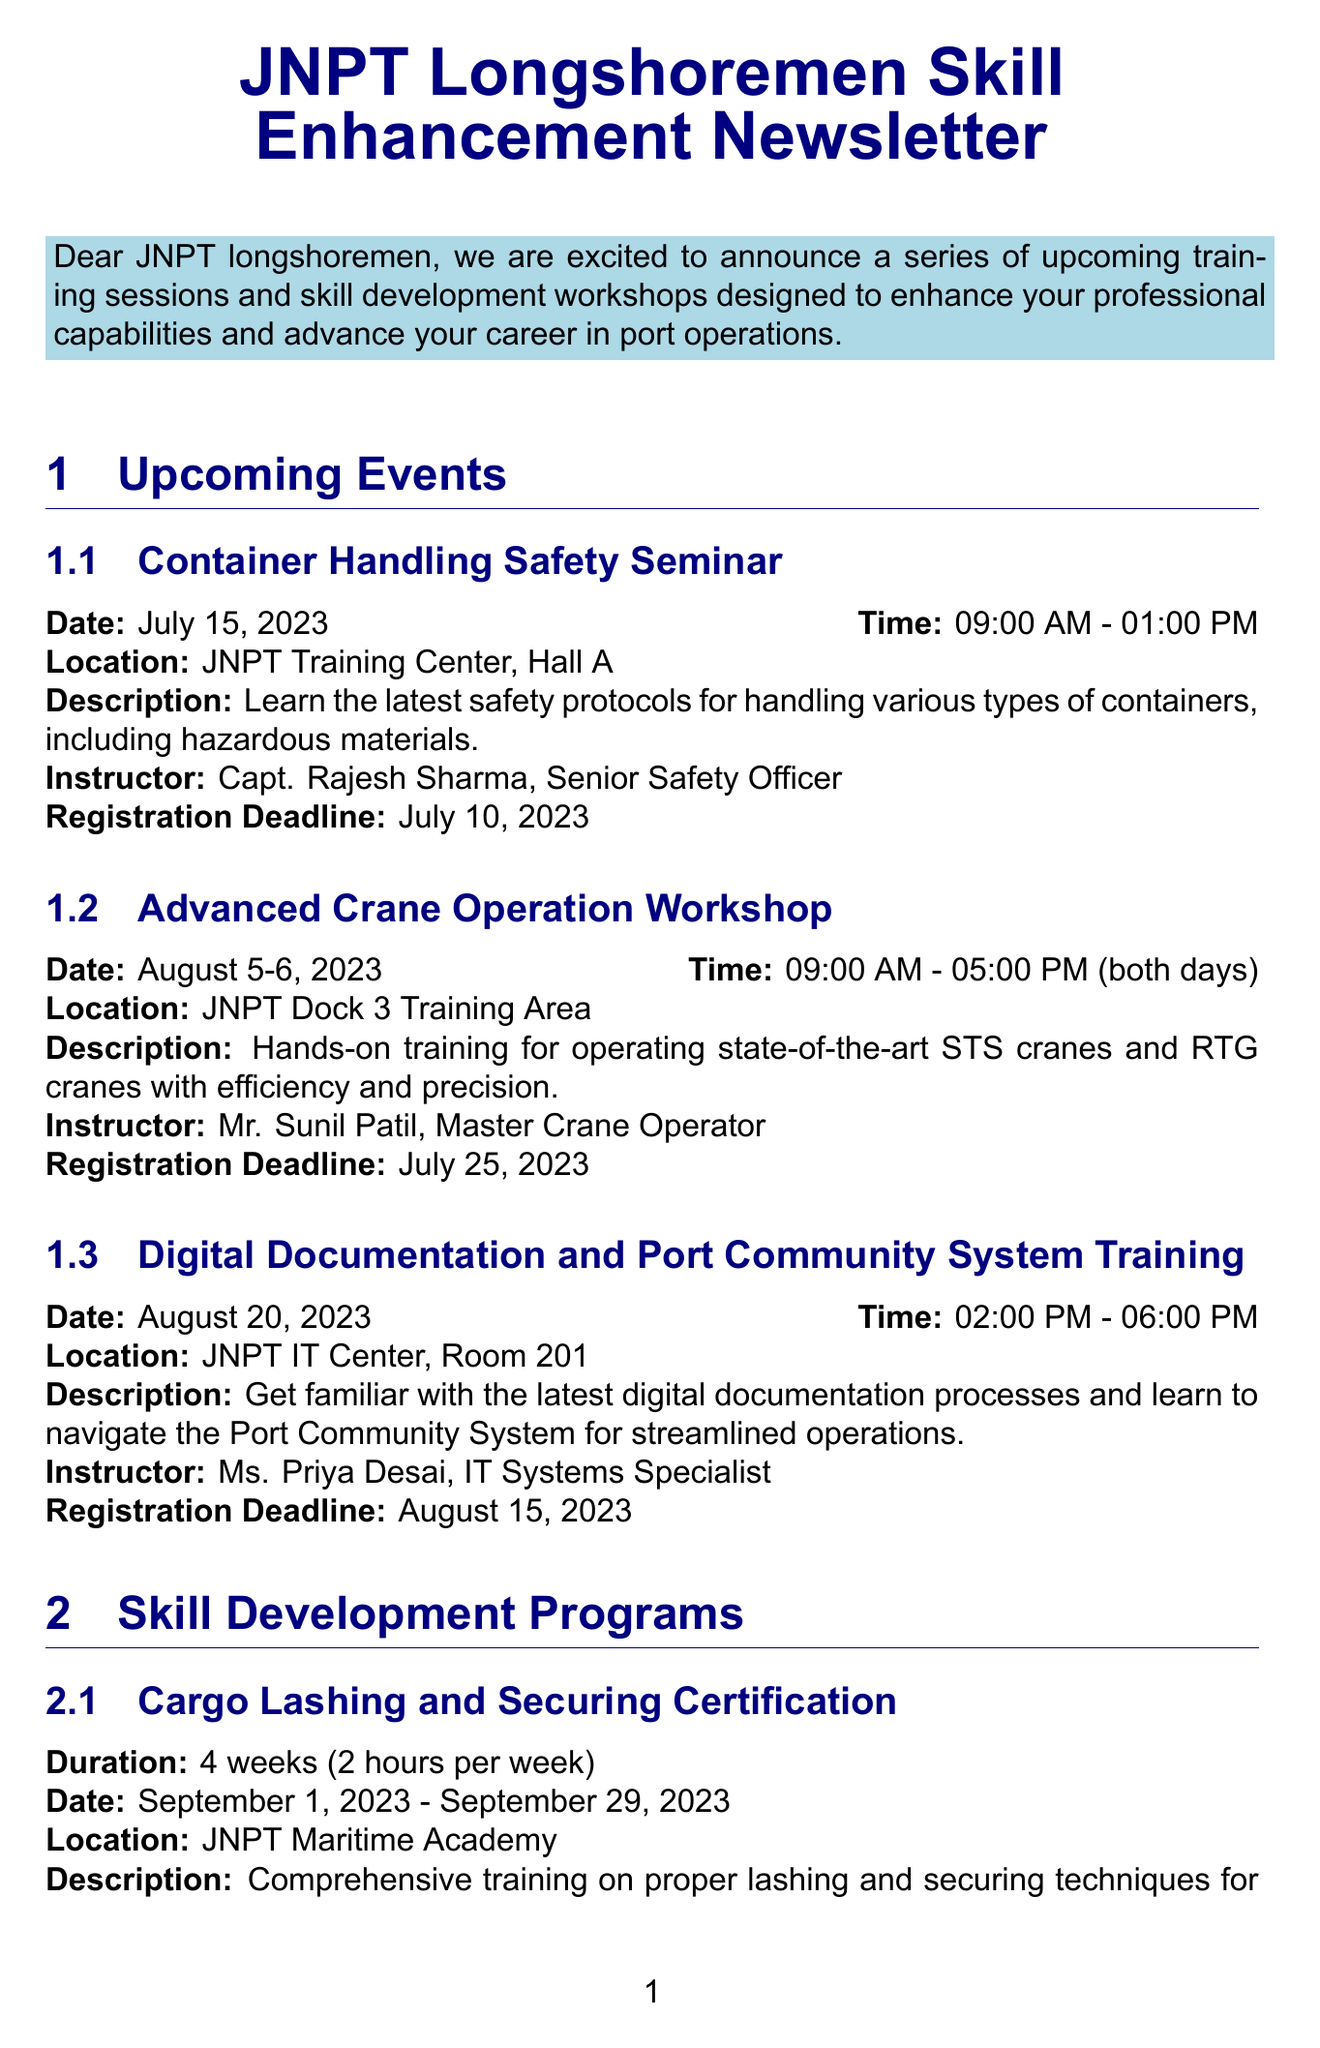What is the title of the newsletter? The title of the newsletter is provided at the beginning of the document.
Answer: JNPT Longshoremen Skill Enhancement Newsletter When is the registration deadline for the Container Handling Safety Seminar? The registration deadline for each event is mentioned in its details.
Answer: July 10, 2023 Who is the instructor for the Advanced Crane Operation Workshop? Each event lists its instructor, which is specified in the description.
Answer: Mr. Sunil Patil How long does the Cargo Lashing and Securing Certification program last? The duration of each program is described in its section.
Answer: 4 weeks (2 hours per week) What is the date for the Environmental Compliance in Port Operations program? The date is explicitly mentioned in the program details section.
Answer: October 7-8, 2023 Where is the Digital Documentation and Port Community System Training held? The location for each event is specified under its details.
Answer: JNPT IT Center, Room 201 What kind of certificate will participants receive upon completion of the programs? The document states the type of certification provided after completion of programs.
Answer: Professional certification Who should participants contact for registration inquiries? The contact person for registration is named in the registration information section.
Answer: Mr. Prakash Rao 